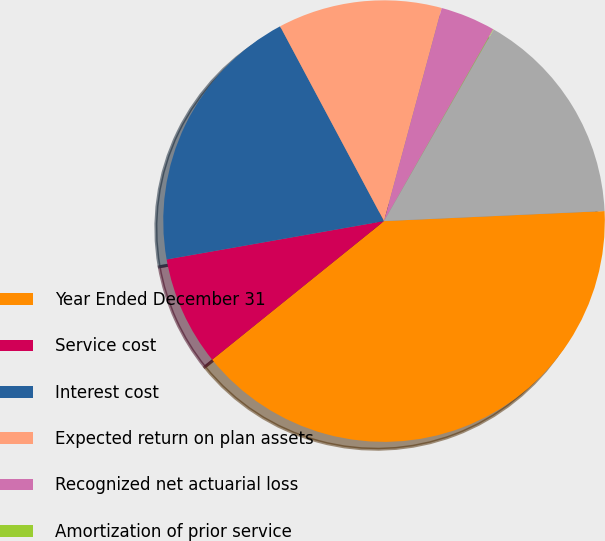Convert chart to OTSL. <chart><loc_0><loc_0><loc_500><loc_500><pie_chart><fcel>Year Ended December 31<fcel>Service cost<fcel>Interest cost<fcel>Expected return on plan assets<fcel>Recognized net actuarial loss<fcel>Amortization of prior service<fcel>Annual benefit cost<nl><fcel>39.93%<fcel>8.02%<fcel>19.98%<fcel>12.01%<fcel>4.03%<fcel>0.04%<fcel>16.0%<nl></chart> 